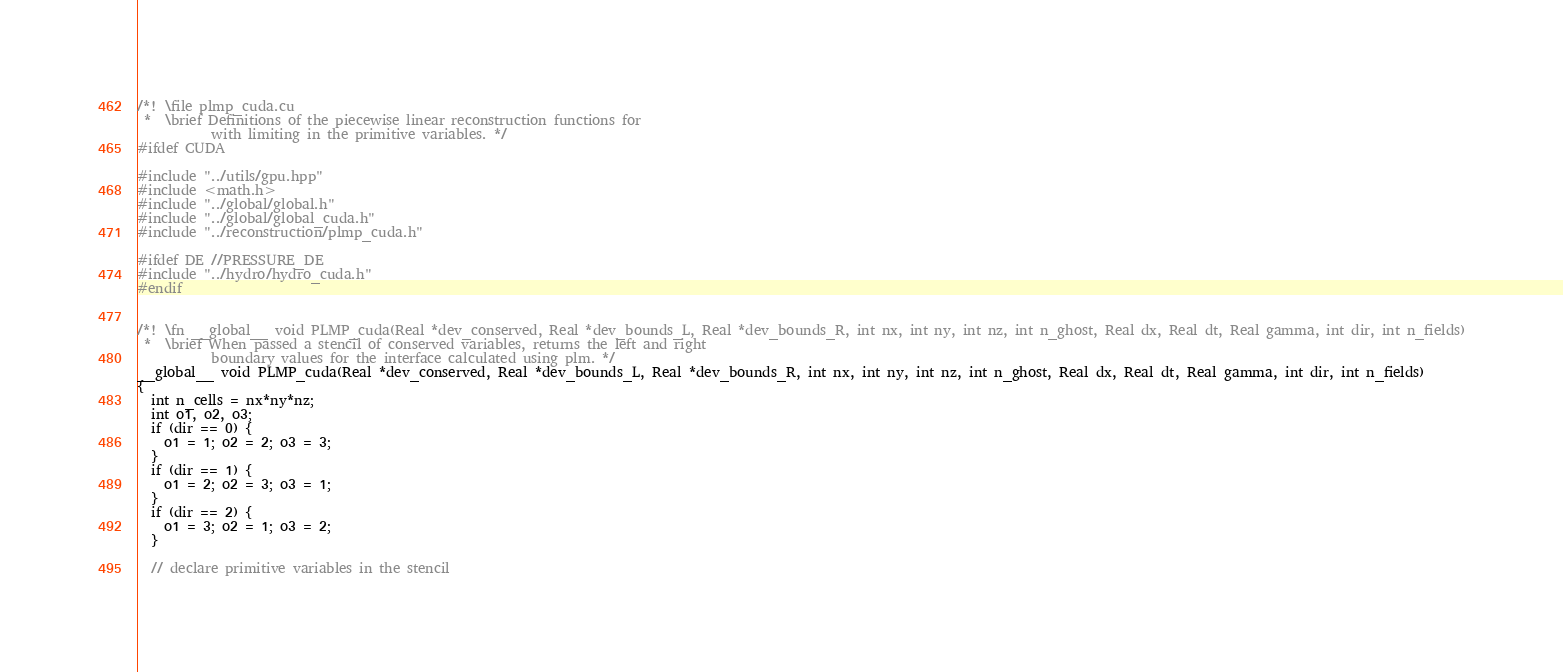Convert code to text. <code><loc_0><loc_0><loc_500><loc_500><_Cuda_>/*! \file plmp_cuda.cu
 *  \brief Definitions of the piecewise linear reconstruction functions for
           with limiting in the primitive variables. */
#ifdef CUDA

#include "../utils/gpu.hpp"
#include <math.h>
#include "../global/global.h"
#include "../global/global_cuda.h"
#include "../reconstruction/plmp_cuda.h"

#ifdef DE //PRESSURE_DE
#include "../hydro/hydro_cuda.h"
#endif


/*! \fn __global__ void PLMP_cuda(Real *dev_conserved, Real *dev_bounds_L, Real *dev_bounds_R, int nx, int ny, int nz, int n_ghost, Real dx, Real dt, Real gamma, int dir, int n_fields)
 *  \brief When passed a stencil of conserved variables, returns the left and right
           boundary values for the interface calculated using plm. */
__global__ void PLMP_cuda(Real *dev_conserved, Real *dev_bounds_L, Real *dev_bounds_R, int nx, int ny, int nz, int n_ghost, Real dx, Real dt, Real gamma, int dir, int n_fields)
{
  int n_cells = nx*ny*nz;
  int o1, o2, o3;
  if (dir == 0) {
    o1 = 1; o2 = 2; o3 = 3;
  }
  if (dir == 1) {
    o1 = 2; o2 = 3; o3 = 1;
  }
  if (dir == 2) {
    o1 = 3; o2 = 1; o3 = 2;
  }

  // declare primitive variables in the stencil</code> 